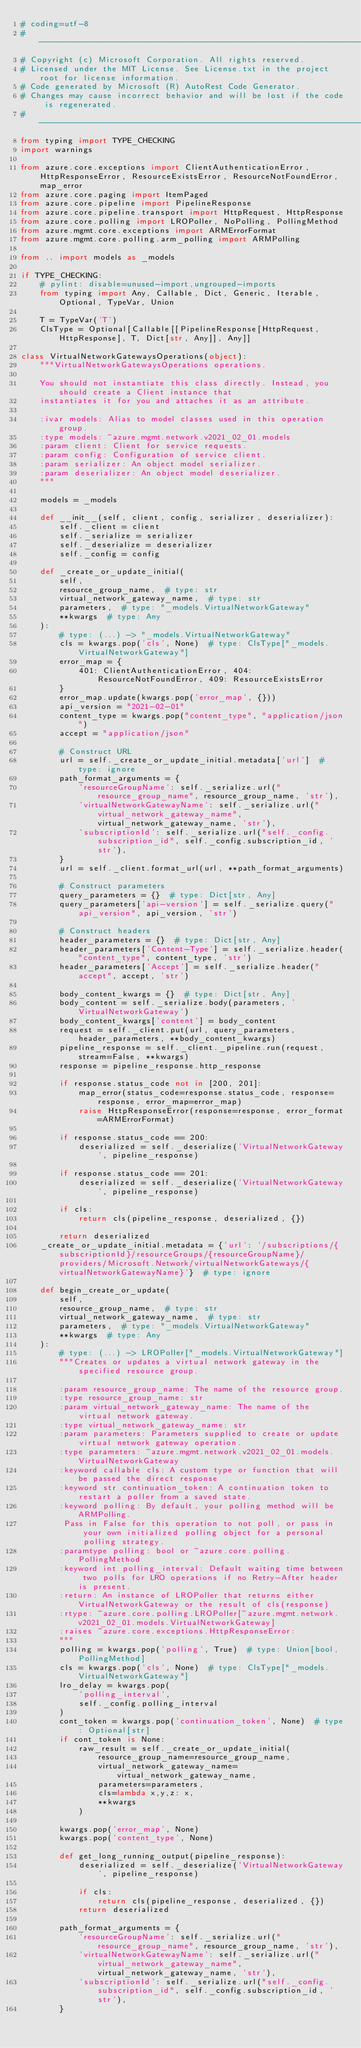Convert code to text. <code><loc_0><loc_0><loc_500><loc_500><_Python_># coding=utf-8
# --------------------------------------------------------------------------
# Copyright (c) Microsoft Corporation. All rights reserved.
# Licensed under the MIT License. See License.txt in the project root for license information.
# Code generated by Microsoft (R) AutoRest Code Generator.
# Changes may cause incorrect behavior and will be lost if the code is regenerated.
# --------------------------------------------------------------------------
from typing import TYPE_CHECKING
import warnings

from azure.core.exceptions import ClientAuthenticationError, HttpResponseError, ResourceExistsError, ResourceNotFoundError, map_error
from azure.core.paging import ItemPaged
from azure.core.pipeline import PipelineResponse
from azure.core.pipeline.transport import HttpRequest, HttpResponse
from azure.core.polling import LROPoller, NoPolling, PollingMethod
from azure.mgmt.core.exceptions import ARMErrorFormat
from azure.mgmt.core.polling.arm_polling import ARMPolling

from .. import models as _models

if TYPE_CHECKING:
    # pylint: disable=unused-import,ungrouped-imports
    from typing import Any, Callable, Dict, Generic, Iterable, Optional, TypeVar, Union

    T = TypeVar('T')
    ClsType = Optional[Callable[[PipelineResponse[HttpRequest, HttpResponse], T, Dict[str, Any]], Any]]

class VirtualNetworkGatewaysOperations(object):
    """VirtualNetworkGatewaysOperations operations.

    You should not instantiate this class directly. Instead, you should create a Client instance that
    instantiates it for you and attaches it as an attribute.

    :ivar models: Alias to model classes used in this operation group.
    :type models: ~azure.mgmt.network.v2021_02_01.models
    :param client: Client for service requests.
    :param config: Configuration of service client.
    :param serializer: An object model serializer.
    :param deserializer: An object model deserializer.
    """

    models = _models

    def __init__(self, client, config, serializer, deserializer):
        self._client = client
        self._serialize = serializer
        self._deserialize = deserializer
        self._config = config

    def _create_or_update_initial(
        self,
        resource_group_name,  # type: str
        virtual_network_gateway_name,  # type: str
        parameters,  # type: "_models.VirtualNetworkGateway"
        **kwargs  # type: Any
    ):
        # type: (...) -> "_models.VirtualNetworkGateway"
        cls = kwargs.pop('cls', None)  # type: ClsType["_models.VirtualNetworkGateway"]
        error_map = {
            401: ClientAuthenticationError, 404: ResourceNotFoundError, 409: ResourceExistsError
        }
        error_map.update(kwargs.pop('error_map', {}))
        api_version = "2021-02-01"
        content_type = kwargs.pop("content_type", "application/json")
        accept = "application/json"

        # Construct URL
        url = self._create_or_update_initial.metadata['url']  # type: ignore
        path_format_arguments = {
            'resourceGroupName': self._serialize.url("resource_group_name", resource_group_name, 'str'),
            'virtualNetworkGatewayName': self._serialize.url("virtual_network_gateway_name", virtual_network_gateway_name, 'str'),
            'subscriptionId': self._serialize.url("self._config.subscription_id", self._config.subscription_id, 'str'),
        }
        url = self._client.format_url(url, **path_format_arguments)

        # Construct parameters
        query_parameters = {}  # type: Dict[str, Any]
        query_parameters['api-version'] = self._serialize.query("api_version", api_version, 'str')

        # Construct headers
        header_parameters = {}  # type: Dict[str, Any]
        header_parameters['Content-Type'] = self._serialize.header("content_type", content_type, 'str')
        header_parameters['Accept'] = self._serialize.header("accept", accept, 'str')

        body_content_kwargs = {}  # type: Dict[str, Any]
        body_content = self._serialize.body(parameters, 'VirtualNetworkGateway')
        body_content_kwargs['content'] = body_content
        request = self._client.put(url, query_parameters, header_parameters, **body_content_kwargs)
        pipeline_response = self._client._pipeline.run(request, stream=False, **kwargs)
        response = pipeline_response.http_response

        if response.status_code not in [200, 201]:
            map_error(status_code=response.status_code, response=response, error_map=error_map)
            raise HttpResponseError(response=response, error_format=ARMErrorFormat)

        if response.status_code == 200:
            deserialized = self._deserialize('VirtualNetworkGateway', pipeline_response)

        if response.status_code == 201:
            deserialized = self._deserialize('VirtualNetworkGateway', pipeline_response)

        if cls:
            return cls(pipeline_response, deserialized, {})

        return deserialized
    _create_or_update_initial.metadata = {'url': '/subscriptions/{subscriptionId}/resourceGroups/{resourceGroupName}/providers/Microsoft.Network/virtualNetworkGateways/{virtualNetworkGatewayName}'}  # type: ignore

    def begin_create_or_update(
        self,
        resource_group_name,  # type: str
        virtual_network_gateway_name,  # type: str
        parameters,  # type: "_models.VirtualNetworkGateway"
        **kwargs  # type: Any
    ):
        # type: (...) -> LROPoller["_models.VirtualNetworkGateway"]
        """Creates or updates a virtual network gateway in the specified resource group.

        :param resource_group_name: The name of the resource group.
        :type resource_group_name: str
        :param virtual_network_gateway_name: The name of the virtual network gateway.
        :type virtual_network_gateway_name: str
        :param parameters: Parameters supplied to create or update virtual network gateway operation.
        :type parameters: ~azure.mgmt.network.v2021_02_01.models.VirtualNetworkGateway
        :keyword callable cls: A custom type or function that will be passed the direct response
        :keyword str continuation_token: A continuation token to restart a poller from a saved state.
        :keyword polling: By default, your polling method will be ARMPolling.
         Pass in False for this operation to not poll, or pass in your own initialized polling object for a personal polling strategy.
        :paramtype polling: bool or ~azure.core.polling.PollingMethod
        :keyword int polling_interval: Default waiting time between two polls for LRO operations if no Retry-After header is present.
        :return: An instance of LROPoller that returns either VirtualNetworkGateway or the result of cls(response)
        :rtype: ~azure.core.polling.LROPoller[~azure.mgmt.network.v2021_02_01.models.VirtualNetworkGateway]
        :raises ~azure.core.exceptions.HttpResponseError:
        """
        polling = kwargs.pop('polling', True)  # type: Union[bool, PollingMethod]
        cls = kwargs.pop('cls', None)  # type: ClsType["_models.VirtualNetworkGateway"]
        lro_delay = kwargs.pop(
            'polling_interval',
            self._config.polling_interval
        )
        cont_token = kwargs.pop('continuation_token', None)  # type: Optional[str]
        if cont_token is None:
            raw_result = self._create_or_update_initial(
                resource_group_name=resource_group_name,
                virtual_network_gateway_name=virtual_network_gateway_name,
                parameters=parameters,
                cls=lambda x,y,z: x,
                **kwargs
            )

        kwargs.pop('error_map', None)
        kwargs.pop('content_type', None)

        def get_long_running_output(pipeline_response):
            deserialized = self._deserialize('VirtualNetworkGateway', pipeline_response)

            if cls:
                return cls(pipeline_response, deserialized, {})
            return deserialized

        path_format_arguments = {
            'resourceGroupName': self._serialize.url("resource_group_name", resource_group_name, 'str'),
            'virtualNetworkGatewayName': self._serialize.url("virtual_network_gateway_name", virtual_network_gateway_name, 'str'),
            'subscriptionId': self._serialize.url("self._config.subscription_id", self._config.subscription_id, 'str'),
        }
</code> 